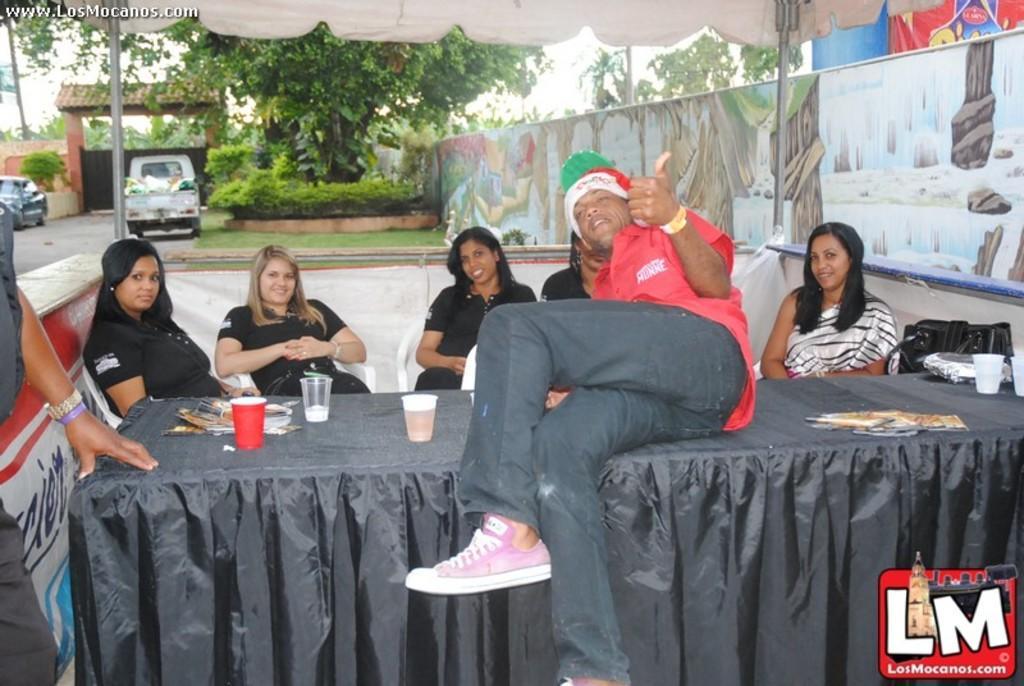Can you describe this image briefly? These persons are sitting on the chair. This person sitting on table. This person standing. We can see table and chairs. On the table we can see glass and things. On the background we can see vehicles,road,tree,sky,gate. 